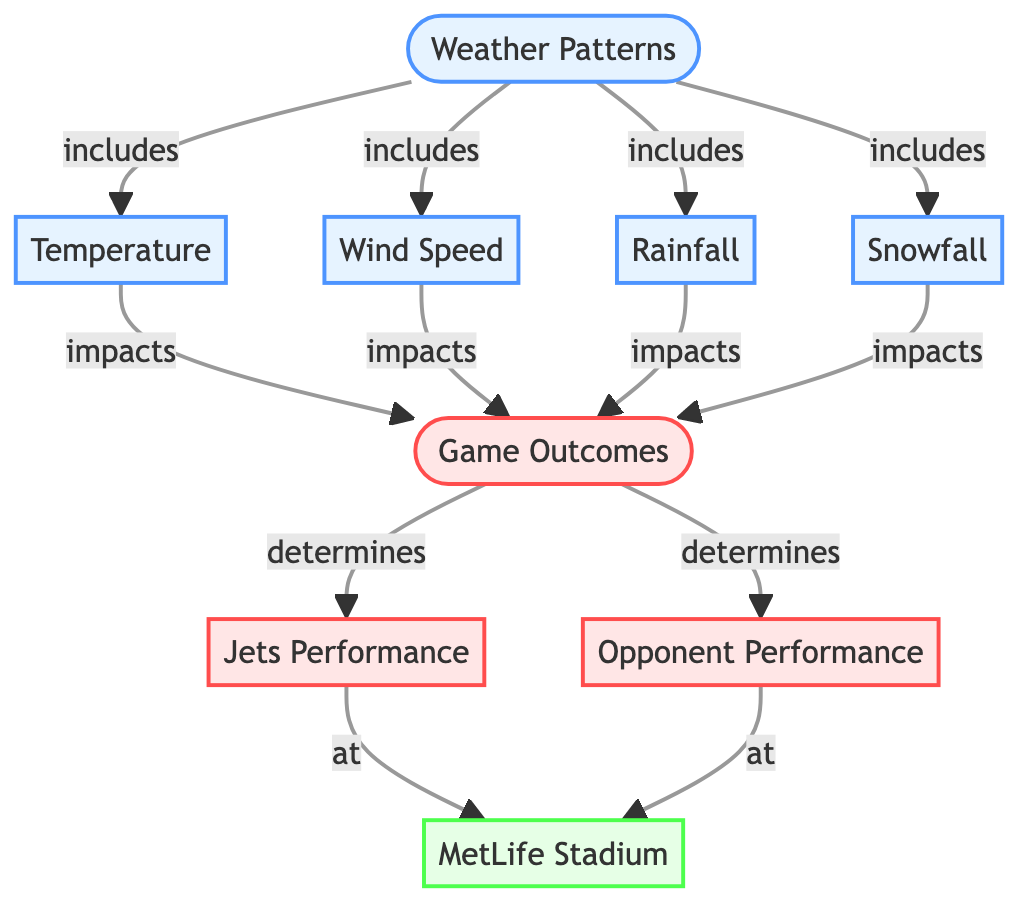What are the components included in Weather Patterns? The diagram shows that Weather Patterns includes Temperature, Wind Speed, Rainfall, and Snowfall as its components. Each component is directly linked to the Weather Patterns node in the diagram.
Answer: Temperature, Wind Speed, Rainfall, Snowfall How many main nodes are there in the diagram? The main nodes in the diagram are Weather Patterns, Game Outcomes, Jets Performance, Opponent Performance, and MetLife Stadium. Counting these nodes gives a total of five main nodes.
Answer: 5 What impact does Temperature have on Game Outcomes? The diagram indicates that Temperature impacts Game Outcomes, as shown by the direct arrow linking Temperature to Game Outcomes. This demonstrates that changes in Temperature can influence the outcomes of games.
Answer: impacts How does Wind Speed relate to Jets Performance? Wind Speed impacts Game Outcomes, and since Game Outcomes determine Jets Performance, we can infer that Wind Speed indirectly affects Jets Performance through its impact on Game Outcomes. This relationship involves two steps in the flow of the diagram.
Answer: indirectly affects Which entities are specified as performances in the diagram? The diagram specifies Jets Performance and Opponent Performance as the entities classified under Game Outcomes. These performances are directly influenced by the outcomes of games at MetLife Stadium.
Answer: Jets Performance, Opponent Performance What is the role of MetLife Stadium in the context of the diagram? MetLife Stadium serves as the location where Jets Performance and Opponent Performance occur. The diagram highlights that both performances are evaluated specifically at MetLife Stadium as depicted in the final nodes connected to the Game Outcomes.
Answer: location What flows from Weather Patterns to Game Outcomes? The components of Weather Patterns, specifically Temperature, Wind Speed, Rainfall, and Snowfall, all flow into Game Outcomes directly based on the connections illustrated in the diagram. This flow signifies that weather conditions affect game results.
Answer: Weather Patterns How many weather factors are shown in the diagram? The diagram presents four specific weather factors: Temperature, Wind Speed, Rainfall, and Snowfall. Each element focuses on a different aspect of weather that could impact game outcomes.
Answer: 4 What type of diagram is this? This diagram is a flowchart because it illustrates the relationships and flow of information among different components, particularly focusing on weather patterns and their subsequent effect on game outcomes.
Answer: flowchart 